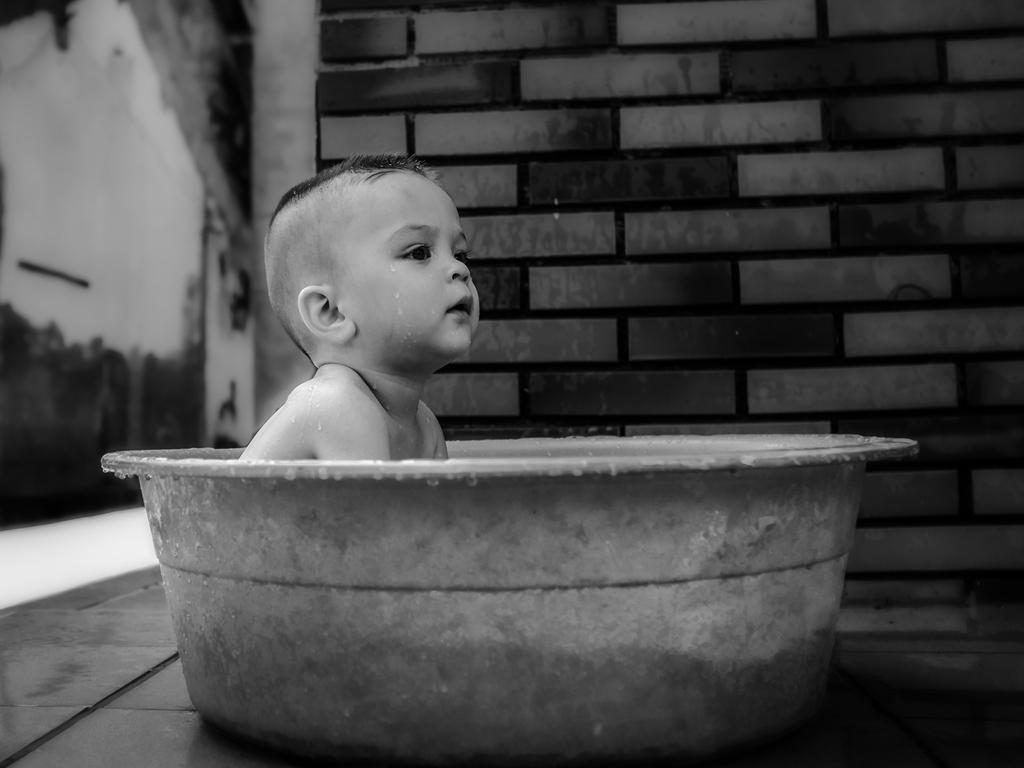What is the main subject of the image? The main subject of the image is a kid. Where is the kid located in the image? The kid is sitting in a tub. What can be seen in the background of the image? There is a wall in the background of the image. How many friends can be seen flying planes in the image? There are no friends or planes present in the image. 